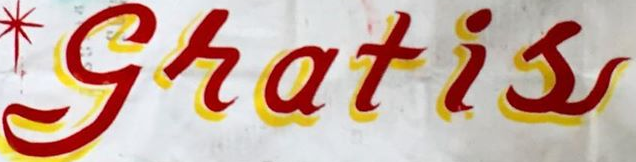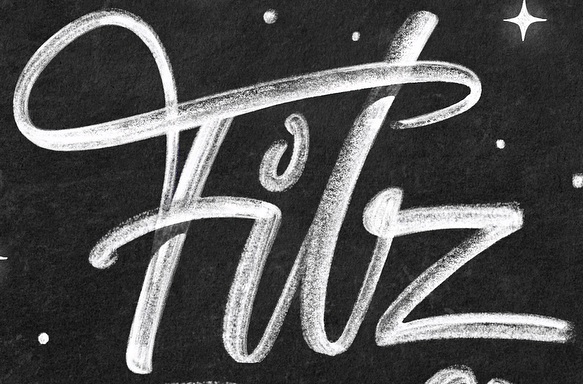Read the text from these images in sequence, separated by a semicolon. gratis; Filz 